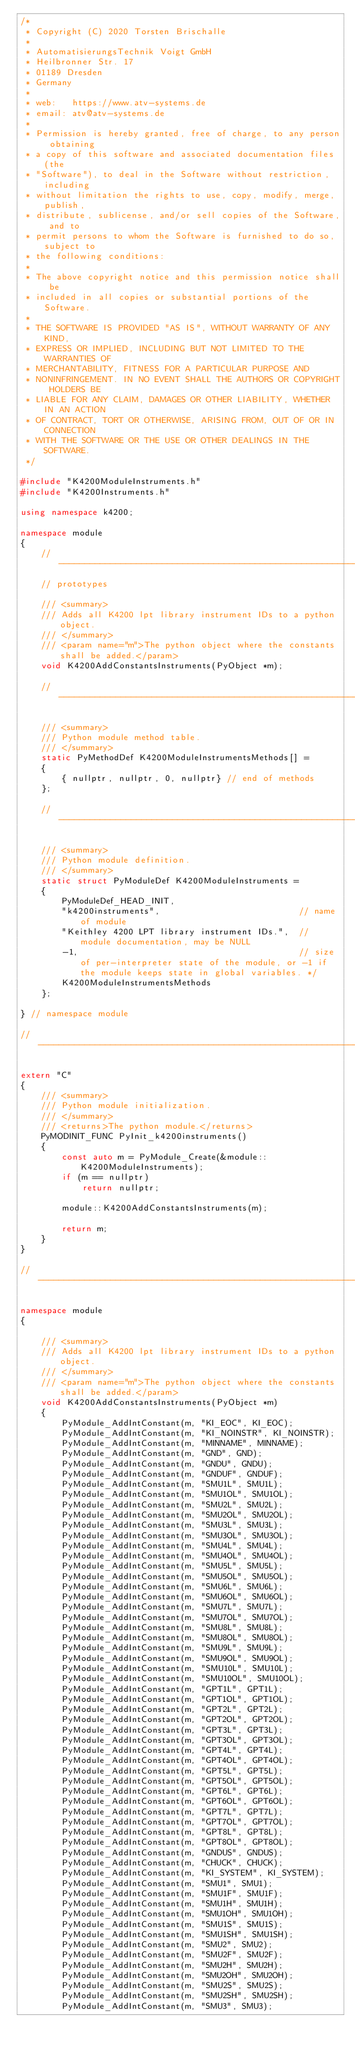<code> <loc_0><loc_0><loc_500><loc_500><_C++_>/*
 * Copyright (C) 2020 Torsten Brischalle
 *
 * AutomatisierungsTechnik Voigt GmbH
 * Heilbronner Str. 17
 * 01189 Dresden
 * Germany
 *
 * web:   https://www.atv-systems.de
 * email: atv@atv-systems.de
 *
 * Permission is hereby granted, free of charge, to any person obtaining
 * a copy of this software and associated documentation files (the
 * "Software"), to deal in the Software without restriction, including
 * without limitation the rights to use, copy, modify, merge, publish,
 * distribute, sublicense, and/or sell copies of the Software, and to
 * permit persons to whom the Software is furnished to do so, subject to
 * the following conditions:
 *
 * The above copyright notice and this permission notice shall be
 * included in all copies or substantial portions of the Software.
 *
 * THE SOFTWARE IS PROVIDED "AS IS", WITHOUT WARRANTY OF ANY KIND,
 * EXPRESS OR IMPLIED, INCLUDING BUT NOT LIMITED TO THE WARRANTIES OF
 * MERCHANTABILITY, FITNESS FOR A PARTICULAR PURPOSE AND
 * NONINFRINGEMENT. IN NO EVENT SHALL THE AUTHORS OR COPYRIGHT HOLDERS BE
 * LIABLE FOR ANY CLAIM, DAMAGES OR OTHER LIABILITY, WHETHER IN AN ACTION
 * OF CONTRACT, TORT OR OTHERWISE, ARISING FROM, OUT OF OR IN CONNECTION
 * WITH THE SOFTWARE OR THE USE OR OTHER DEALINGS IN THE SOFTWARE.
 */

#include "K4200ModuleInstruments.h"
#include "K4200Instruments.h"

using namespace k4200;

namespace module
{
    //-------------------------------------------------------------------------------------------------
    // prototypes

    /// <summary>
    /// Adds all K4200 lpt library instrument IDs to a python object.
    /// </summary>
    /// <param name="m">The python object where the constants shall be added.</param>
    void K4200AddConstantsInstruments(PyObject *m);

    //-------------------------------------------------------------------------------------------------

    /// <summary>
    /// Python module method table.
    /// </summary>
    static PyMethodDef K4200ModuleInstrumentsMethods[] =
    {
        { nullptr, nullptr, 0, nullptr} // end of methods
    };

    //-------------------------------------------------------------------------------------------------

    /// <summary>
    /// Python module definition.
    /// </summary>
    static struct PyModuleDef K4200ModuleInstruments =
    {
        PyModuleDef_HEAD_INIT,
        "k4200instruments",                           // name of module
        "Keithley 4200 LPT library instrument IDs.",  // module documentation, may be NULL
        -1,                                           // size of per-interpreter state of the module, or -1 if the module keeps state in global variables. */
        K4200ModuleInstrumentsMethods
    };

} // namespace module

//-------------------------------------------------------------------------------------------------

extern "C"
{
    /// <summary>
    /// Python module initialization.
    /// </summary>
    /// <returns>The python module.</returns>
    PyMODINIT_FUNC PyInit_k4200instruments()
    {
        const auto m = PyModule_Create(&module::K4200ModuleInstruments);
        if (m == nullptr)
            return nullptr;

        module::K4200AddConstantsInstruments(m);

        return m;
    }
}

//-------------------------------------------------------------------------------------------------

namespace module
{

    /// <summary>
    /// Adds all K4200 lpt library instrument IDs to a python object.
    /// </summary>
    /// <param name="m">The python object where the constants shall be added.</param>
    void K4200AddConstantsInstruments(PyObject *m)
    {
        PyModule_AddIntConstant(m, "KI_EOC", KI_EOC);
        PyModule_AddIntConstant(m, "KI_NOINSTR", KI_NOINSTR);
        PyModule_AddIntConstant(m, "MINNAME", MINNAME);
        PyModule_AddIntConstant(m, "GND", GND);
        PyModule_AddIntConstant(m, "GNDU", GNDU);
        PyModule_AddIntConstant(m, "GNDUF", GNDUF);
        PyModule_AddIntConstant(m, "SMU1L", SMU1L);
        PyModule_AddIntConstant(m, "SMU1OL", SMU1OL);
        PyModule_AddIntConstant(m, "SMU2L", SMU2L);
        PyModule_AddIntConstant(m, "SMU2OL", SMU2OL);
        PyModule_AddIntConstant(m, "SMU3L", SMU3L);
        PyModule_AddIntConstant(m, "SMU3OL", SMU3OL);
        PyModule_AddIntConstant(m, "SMU4L", SMU4L);
        PyModule_AddIntConstant(m, "SMU4OL", SMU4OL);
        PyModule_AddIntConstant(m, "SMU5L", SMU5L);
        PyModule_AddIntConstant(m, "SMU5OL", SMU5OL);
        PyModule_AddIntConstant(m, "SMU6L", SMU6L);
        PyModule_AddIntConstant(m, "SMU6OL", SMU6OL);
        PyModule_AddIntConstant(m, "SMU7L", SMU7L);
        PyModule_AddIntConstant(m, "SMU7OL", SMU7OL);
        PyModule_AddIntConstant(m, "SMU8L", SMU8L);
        PyModule_AddIntConstant(m, "SMU8OL", SMU8OL);
        PyModule_AddIntConstant(m, "SMU9L", SMU9L);
        PyModule_AddIntConstant(m, "SMU9OL", SMU9OL);
        PyModule_AddIntConstant(m, "SMU10L", SMU10L);
        PyModule_AddIntConstant(m, "SMU10OL", SMU10OL);
        PyModule_AddIntConstant(m, "GPT1L", GPT1L);
        PyModule_AddIntConstant(m, "GPT1OL", GPT1OL);
        PyModule_AddIntConstant(m, "GPT2L", GPT2L);
        PyModule_AddIntConstant(m, "GPT2OL", GPT2OL);
        PyModule_AddIntConstant(m, "GPT3L", GPT3L);
        PyModule_AddIntConstant(m, "GPT3OL", GPT3OL);
        PyModule_AddIntConstant(m, "GPT4L", GPT4L);
        PyModule_AddIntConstant(m, "GPT4OL", GPT4OL);
        PyModule_AddIntConstant(m, "GPT5L", GPT5L);
        PyModule_AddIntConstant(m, "GPT5OL", GPT5OL);
        PyModule_AddIntConstant(m, "GPT6L", GPT6L);
        PyModule_AddIntConstant(m, "GPT6OL", GPT6OL);
        PyModule_AddIntConstant(m, "GPT7L", GPT7L);
        PyModule_AddIntConstant(m, "GPT7OL", GPT7OL);
        PyModule_AddIntConstant(m, "GPT8L", GPT8L);
        PyModule_AddIntConstant(m, "GPT8OL", GPT8OL);
        PyModule_AddIntConstant(m, "GNDUS", GNDUS);
        PyModule_AddIntConstant(m, "CHUCK", CHUCK);
        PyModule_AddIntConstant(m, "KI_SYSTEM", KI_SYSTEM);
        PyModule_AddIntConstant(m, "SMU1", SMU1);
        PyModule_AddIntConstant(m, "SMU1F", SMU1F);
        PyModule_AddIntConstant(m, "SMU1H", SMU1H);
        PyModule_AddIntConstant(m, "SMU1OH", SMU1OH);
        PyModule_AddIntConstant(m, "SMU1S", SMU1S);
        PyModule_AddIntConstant(m, "SMU1SH", SMU1SH);
        PyModule_AddIntConstant(m, "SMU2", SMU2);
        PyModule_AddIntConstant(m, "SMU2F", SMU2F);
        PyModule_AddIntConstant(m, "SMU2H", SMU2H);
        PyModule_AddIntConstant(m, "SMU2OH", SMU2OH);
        PyModule_AddIntConstant(m, "SMU2S", SMU2S);
        PyModule_AddIntConstant(m, "SMU2SH", SMU2SH);
        PyModule_AddIntConstant(m, "SMU3", SMU3);</code> 